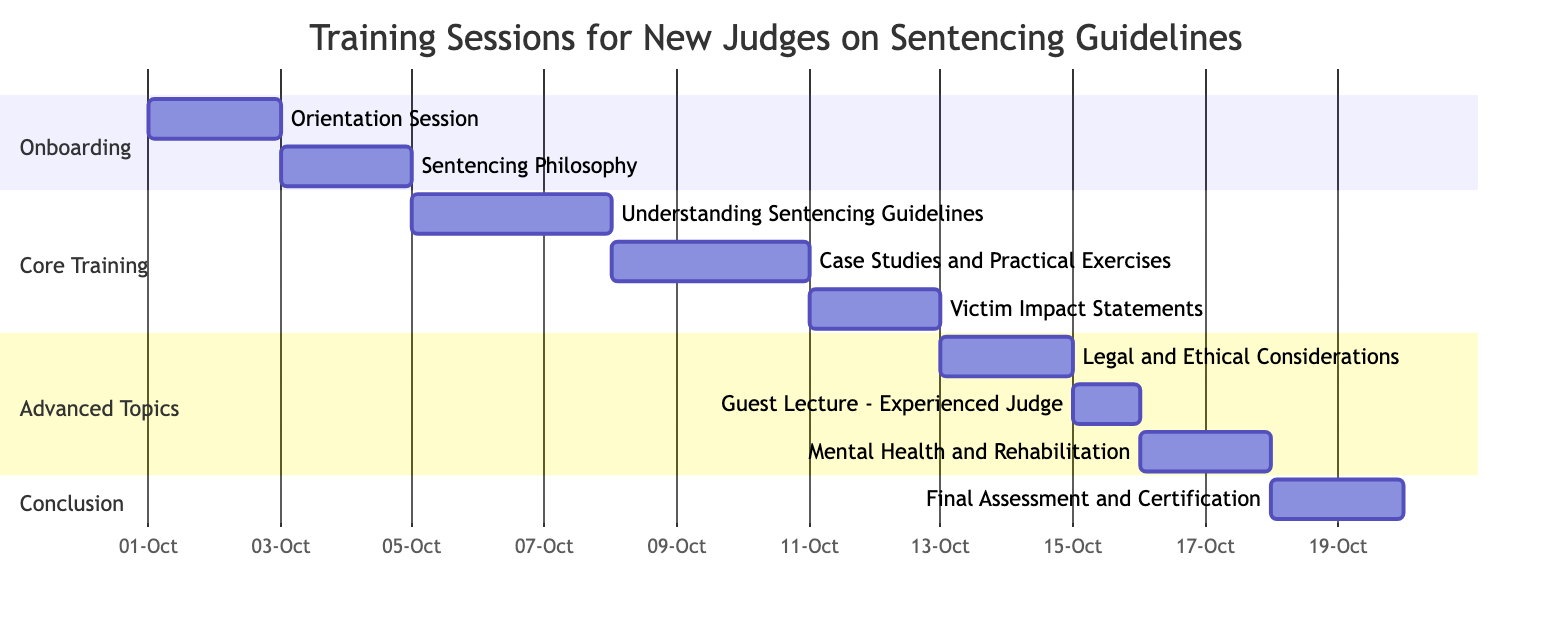What is the total number of training sessions listed in the Gantt chart? The Gantt chart lists all the training sessions in individual sections. By counting them, we find there are a total of 9 distinct training sessions visible in the chart.
Answer: 9 Which training session starts on October 5th? Looking at the timeline, the session "Understanding Sentencing Guidelines" begins on October 5th, showing it's the specific session that aligns with this start date.
Answer: Understanding Sentencing Guidelines How long does the "Case Studies and Practical Exercises" session run? This session starts on October 8th and ends on October 10th; thus, it lasts for 3 days from the start to the end date.
Answer: 3 days Which session occurs immediately after the "Victim Impact Statements"? The "Victim Impact Statements" session ends on October 12th, and the next session "Legal and Ethical Considerations" begins the following day on October 13th. Therefore, this session is the immediate next one.
Answer: Legal and Ethical Considerations What is the duration for the "Final Assessment and Certification"? This session starts on October 18th and ends on October 19th, making it a 2-day session in total according to the dates specified in the chart.
Answer: 2 days How many sections are there in the Gantt chart? The chart is divided into four distinct sections: Onboarding, Core Training, Advanced Topics, and Conclusion, thus offering a structured approach to the training sessions.
Answer: 4 Which session is scheduled to have a guest lecture? The "Guest Lecture - Experienced Judge" is specially indicated in the chart, scheduled for October 15th, reflecting its unique purpose in the training series.
Answer: Guest Lecture - Experienced Judge Which two sessions take place on the same day? The "Orientation Session" and "Sentencing Philosophy" sessions are both scheduled consecutively within the first section, but they each occupy different days, so no sessions coincide on the same day per the chart's layout.
Answer: None What is the last session listed in the training program? Reviewing the final section of the chart named "Conclusion," the last entry is "Final Assessment and Certification," which signifies the completion of the training program.
Answer: Final Assessment and Certification 